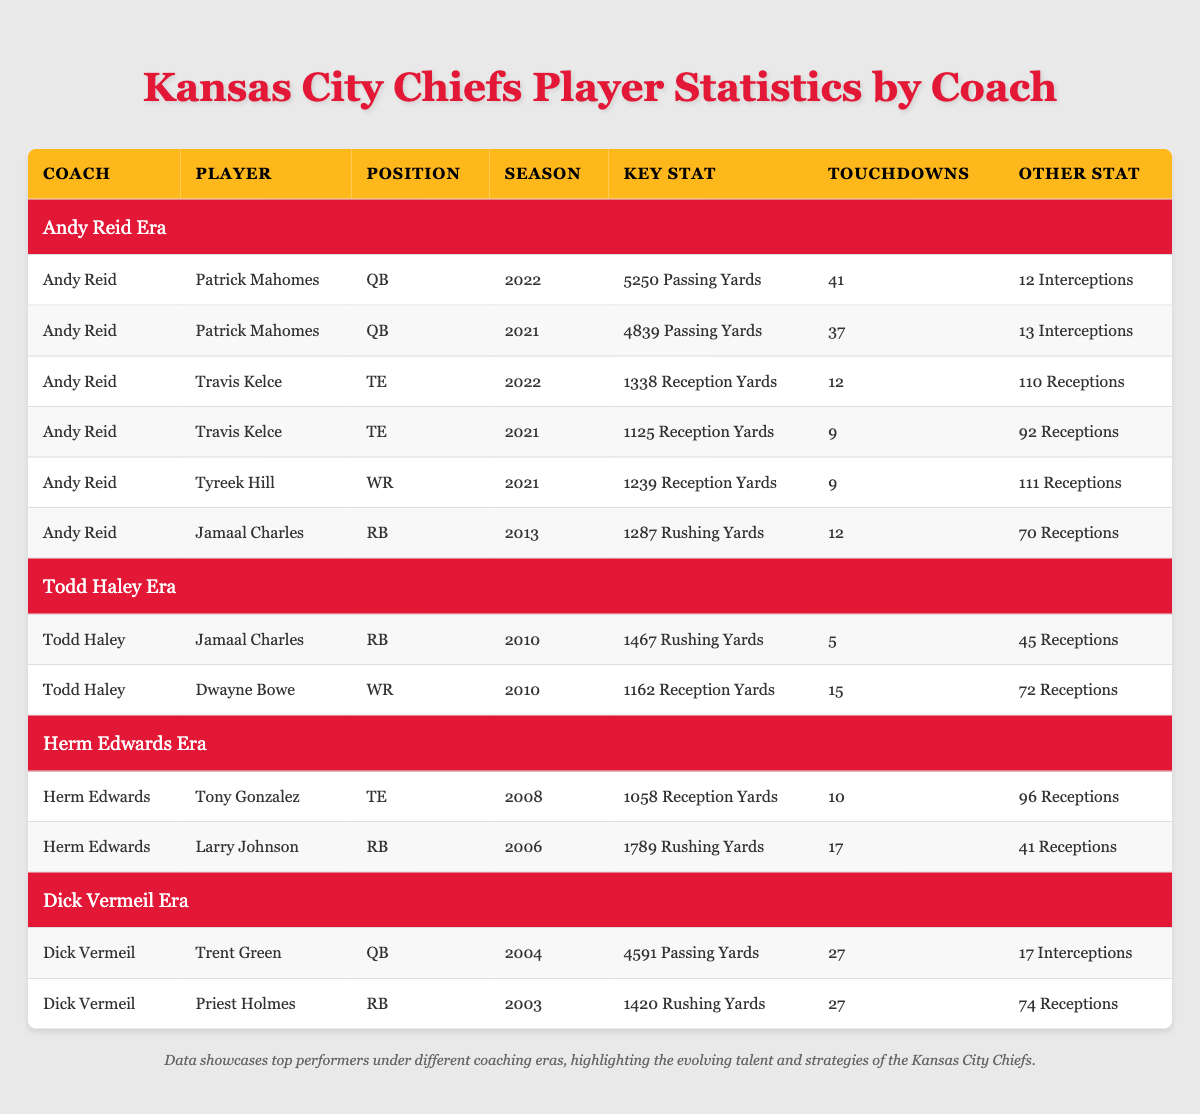What are the passing yards for Patrick Mahomes in the 2022 season? Patrick Mahomes' passing yards in the 2022 season are explicitly listed in the table under his name for that season, which states 5250 passing yards.
Answer: 5250 What is Larry Johnson's touchdown count during the Herm Edwards era? The table shows that Larry Johnson, under the Herm Edwards era in 2006, had a total of 17 touchdowns, mentioned directly next to his name.
Answer: 17 Who had more total rushing yards, Jamaal Charles in 2010 or 2013? Jamaal Charles’ rushing yards are 1467 in 2010 (under Todd Haley) and 1287 in 2013 (under Andy Reid). Comparing these numbers shows that 1467 is greater than 1287, which means he had more in 2010.
Answer: 2010 Did Travis Kelce score more touchdowns in 2022 than in 2021? The table indicates Travis Kelce scored 12 touchdowns in 2022 and 9 in 2021. Therefore, comparing 12 and 9 shows that he scored more in 2022.
Answer: Yes What is the average number of rushing yards for the running backs mentioned in the table? The table lists rushing yards for two running backs: Jamaal Charles (1467 in 2010 and 1287 in 2013) and Larry Johnson (1789 in 2006) and Priest Holmes (1420 in 2003). Adding these gives 1467 + 1287 + 1789 + 1420 = 5163. There are 4 entries, so the average is 5163 / 4 = 1290.75.
Answer: 1290.75 Who had the highest reception yards in the Andy Reid era? Under the Andy Reid era, Travis Kelce has the highest reception yards recorded in 2022 with 1338, which is shown clearly next to his name and season. Comparing it with Mahomes and Tyreek Hill confirms he had the highest.
Answer: 1338 Was Dwayne Bowe's touchdown count higher than Jamaal Charles' in 2010? The table states Dwayne Bowe scored 15 touchdowns in 2010, while Jamaal Charles scored 5 touchdowns in the same season. Since 15 is greater than 5, Dwayne Bowe's touchdown count was higher.
Answer: Yes How many more interceptions did Patrick Mahomes throw in 2021 compared to 2022? In 2021, Patrick Mahomes had 13 interceptions while in 2022 he had 12. To find the difference, subtract 12 from 13, which results in 1 more interception in 2021.
Answer: 1 Which player under coach Dick Vermeil had more passing yards than touchdowns? In the table for Dick Vermeil, Trent Green had 4591 passing yards and 27 touchdowns, while Priest Holmes had 1420 rushing yards and 27 touchdowns. Comparatively, Trent Green's passing yards (4591) exceed his touchdowns (27), fulfilling the criteria.
Answer: Trent Green 